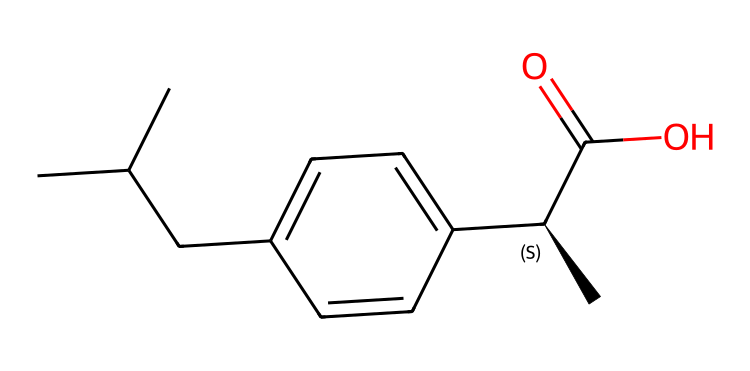What is the molecular formula of ibuprofen? The molecular formula can be determined by counting the number of each type of atom present in the chemical structure (C, H, O). From the SMILES representation, there are 13 carbon atoms (C), 18 hydrogen atoms (H), and 2 oxygen atoms (O). Therefore, the molecular formula is C13H18O2.
Answer: C13H18O2 How many rings are present in the structure of ibuprofen? By analyzing the SMILES, we can look for ring structures. In this case, there are no numbers indicating ring closures. The structure is linear and branched without any cycles. Therefore, the number of rings is zero.
Answer: 0 What functional group is present in ibuprofen? Looking at the structure, the presence of the carboxylic acid (-COOH) group can be noted at the end of the molecule, which is indicated by "C(=O)O" in the SMILES. This is a characteristic functional group for many medicinal compounds, including ibuprofen.
Answer: carboxylic acid How many chiral centers are in ibuprofen? Chiral centers are defined as carbon atoms that are attached to four different substituents. In the given SMILES, the "C@H" notation indicates one chiral carbon with four different groups. Therefore, there is one chiral center in the molecule.
Answer: 1 What type of isomerism is present in ibuprofen? Ibuprofen can exhibit stereoisomerism due to the presence of the chiral center. The molecule can exist as two enantiomers (mirror images of each other) because of this asymmetric carbon. Hence, the type of isomerism present is stereoisomerism.
Answer: stereoisomerism How many total atoms are there in ibuprofen's molecular formula? To find the total number of atoms, we can add the counts of each type of atom from the molecular formula. There are 13 carbons, 18 hydrogens, and 2 oxygens. Therefore, the total is 13 + 18 + 2 = 33.
Answer: 33 